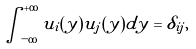Convert formula to latex. <formula><loc_0><loc_0><loc_500><loc_500>\int _ { - \infty } ^ { + \infty } u _ { i } ( y ) u _ { j } ( y ) d y = \delta _ { i j } ,</formula> 